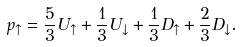Convert formula to latex. <formula><loc_0><loc_0><loc_500><loc_500>p _ { \uparrow } = \frac { 5 } { 3 } U _ { \uparrow } + \frac { 1 } { 3 } U _ { \downarrow } + \frac { 1 } { 3 } D _ { \uparrow } + \frac { 2 } { 3 } D _ { \downarrow } .</formula> 